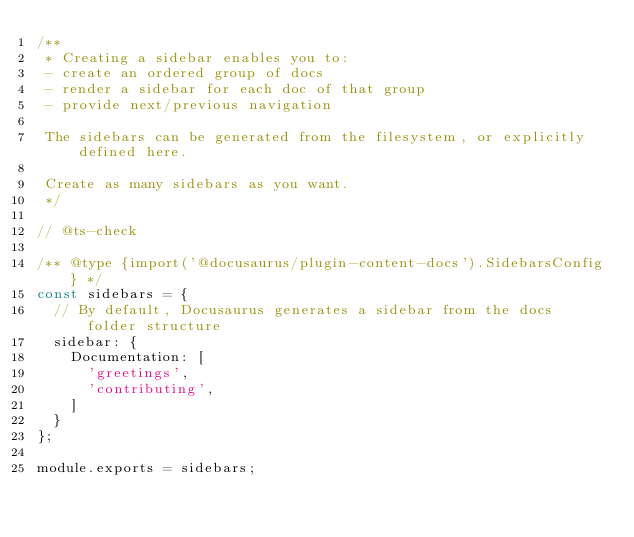Convert code to text. <code><loc_0><loc_0><loc_500><loc_500><_JavaScript_>/**
 * Creating a sidebar enables you to:
 - create an ordered group of docs
 - render a sidebar for each doc of that group
 - provide next/previous navigation

 The sidebars can be generated from the filesystem, or explicitly defined here.

 Create as many sidebars as you want.
 */

// @ts-check

/** @type {import('@docusaurus/plugin-content-docs').SidebarsConfig} */
const sidebars = {
  // By default, Docusaurus generates a sidebar from the docs folder structure
  sidebar: {
    Documentation: [
      'greetings',
      'contributing',
    ]
  }
};

module.exports = sidebars;
</code> 